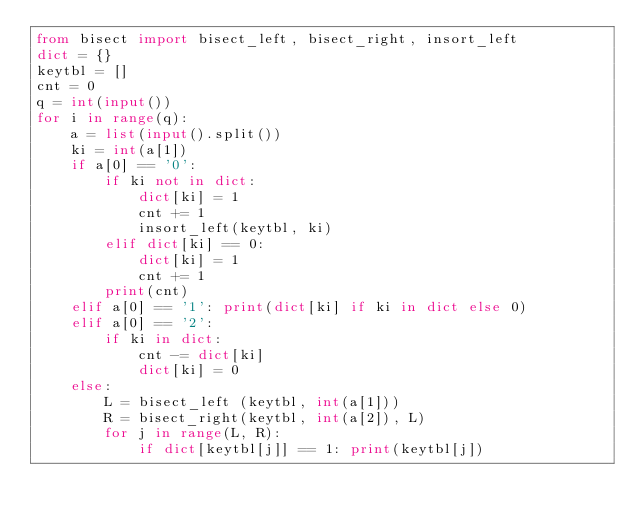Convert code to text. <code><loc_0><loc_0><loc_500><loc_500><_Python_>from bisect import bisect_left, bisect_right, insort_left
dict = {}
keytbl = []
cnt = 0
q = int(input())
for i in range(q):
	a = list(input().split())
	ki = int(a[1])
	if a[0] == '0':
		if ki not in dict:
			dict[ki] = 1
			cnt += 1
			insort_left(keytbl, ki)
		elif dict[ki] == 0:
			dict[ki] = 1
			cnt += 1
		print(cnt)
	elif a[0] == '1': print(dict[ki] if ki in dict else 0)
	elif a[0] == '2':
		if ki in dict:
			cnt -= dict[ki]
			dict[ki] = 0
	else:
		L = bisect_left (keytbl, int(a[1]))
		R = bisect_right(keytbl, int(a[2]), L)
		for j in range(L, R):
			if dict[keytbl[j]] == 1: print(keytbl[j])

</code> 